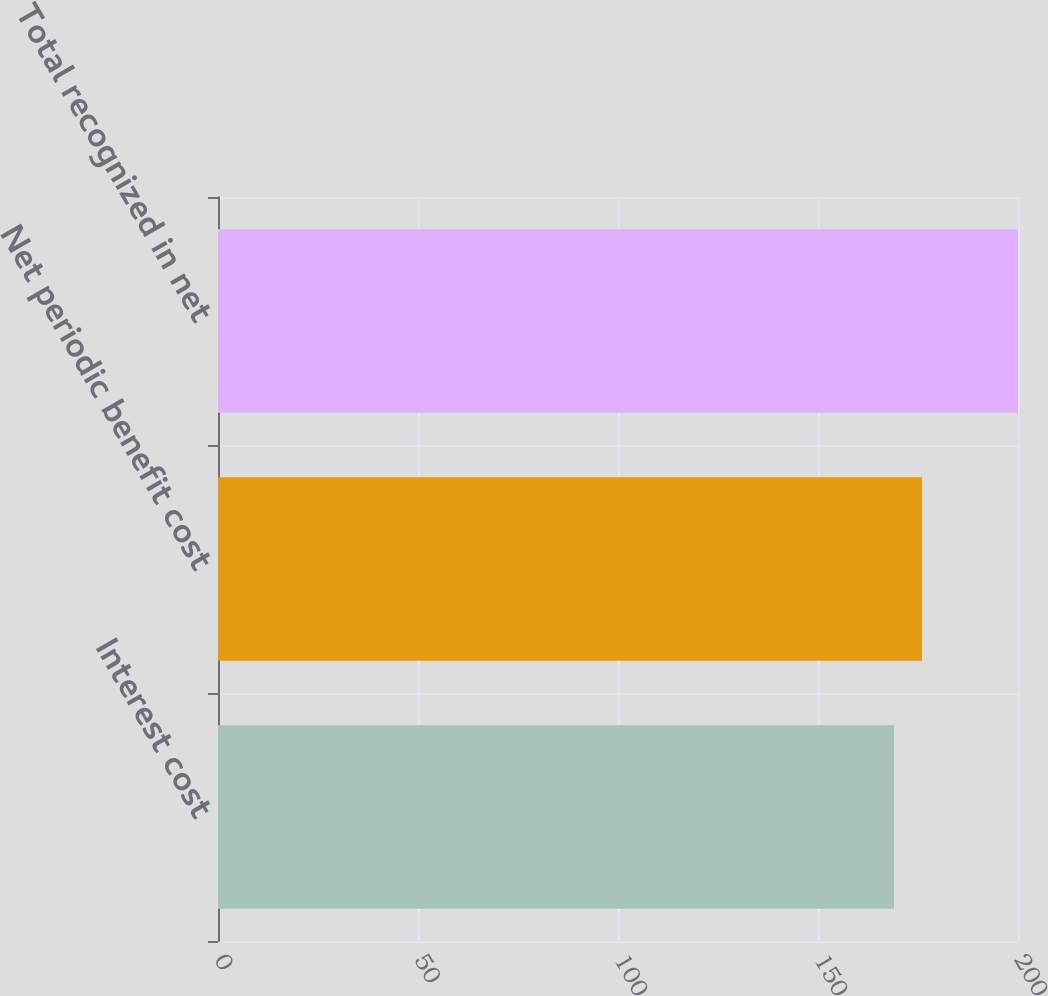<chart> <loc_0><loc_0><loc_500><loc_500><bar_chart><fcel>Interest cost<fcel>Net periodic benefit cost<fcel>Total recognized in net<nl><fcel>169<fcel>176<fcel>200<nl></chart> 